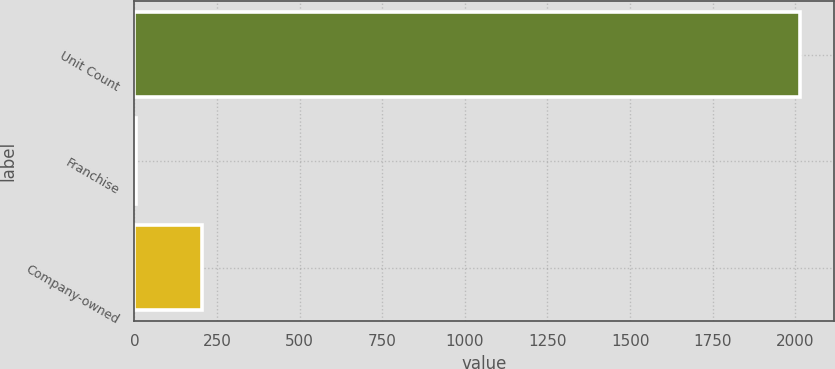Convert chart to OTSL. <chart><loc_0><loc_0><loc_500><loc_500><bar_chart><fcel>Unit Count<fcel>Franchise<fcel>Company-owned<nl><fcel>2015<fcel>4<fcel>205.1<nl></chart> 